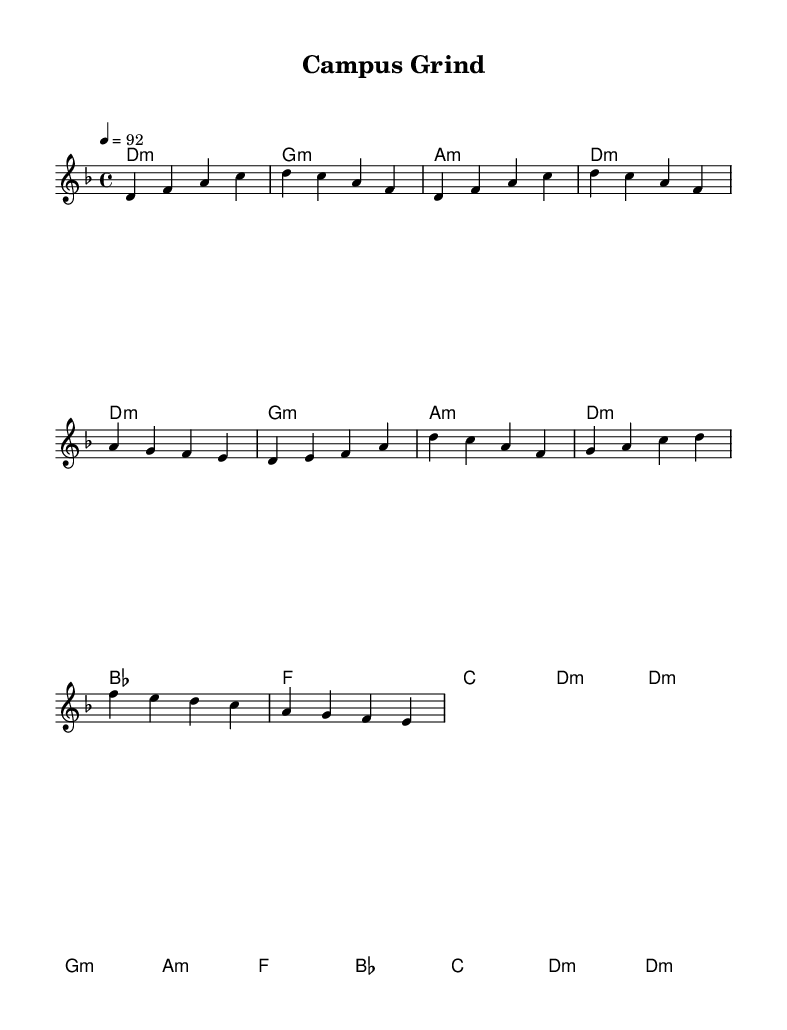What is the key signature of this music? The music is in the key of D minor, which is indicated by the key signature shown at the beginning of the score with one flat (B flat).
Answer: D minor What is the time signature of this piece? The time signature appears at the beginning of the score and shows '4/4', indicating there are four beats in each measure and a quarter note receives one beat.
Answer: 4/4 What is the tempo marking for this composition? The tempo marking is shown as '4 = 92', meaning that there are 92 beats per minute, indicating how fast the piece should be played.
Answer: 92 What is the primary theme of the lyrics? The primary theme of the lyrics addresses the challenges faced by students, particularly about educational pressures and student loans, and emphasizes the value of education.
Answer: Education’s power Which chord is used in the chorus section? The chorus employs a series of chords, and one of the chords that appears within this section is B flat (notated as bes in the score).
Answer: B flat 